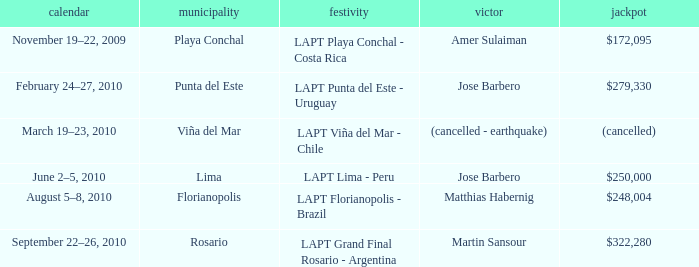What is the date amer sulaiman won? November 19–22, 2009. 